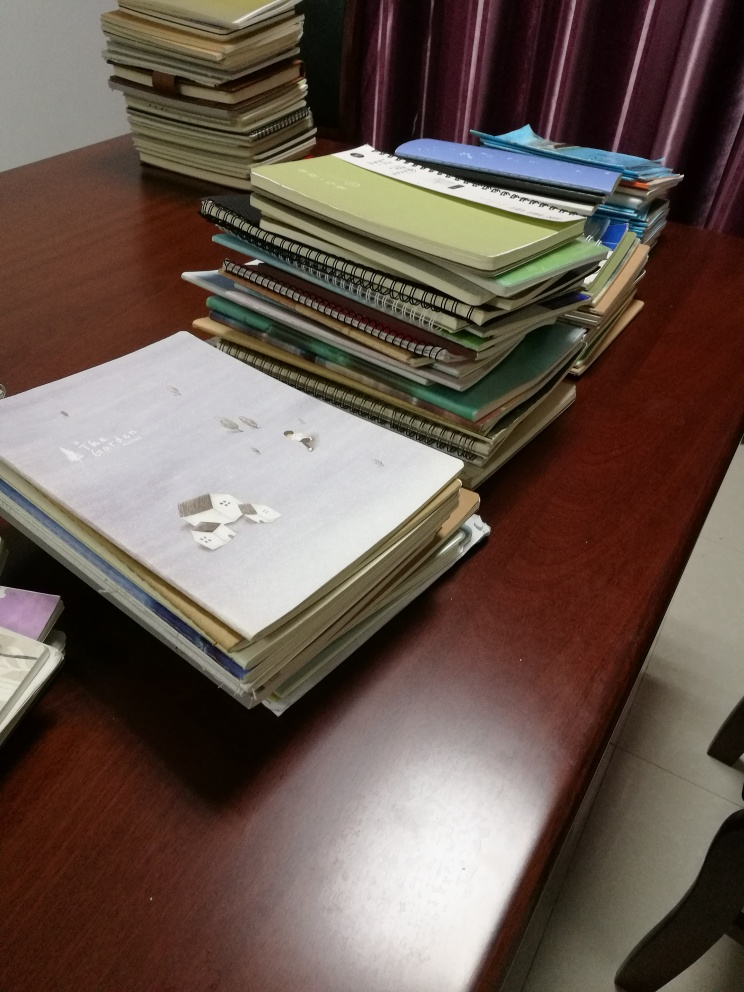Does the image suggest what time of day it is? The image doesn't provide any clear indications of the time of day. There is no visible clock or natural light that could give away the time. The artificial lighting in the room is neutral, so we could be looking at any time during working hours or even later in the evening. 